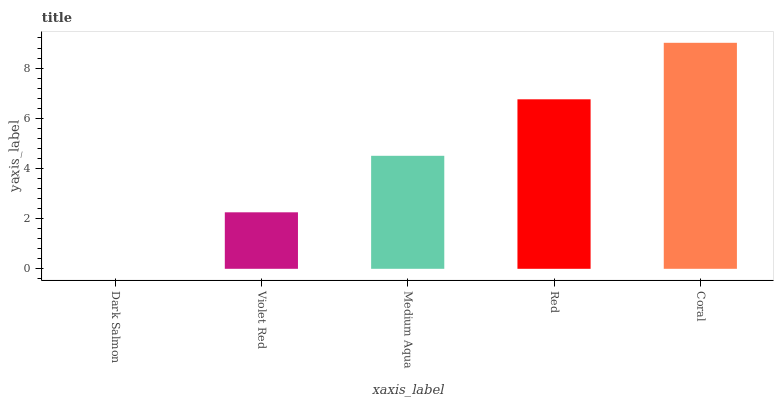Is Dark Salmon the minimum?
Answer yes or no. Yes. Is Coral the maximum?
Answer yes or no. Yes. Is Violet Red the minimum?
Answer yes or no. No. Is Violet Red the maximum?
Answer yes or no. No. Is Violet Red greater than Dark Salmon?
Answer yes or no. Yes. Is Dark Salmon less than Violet Red?
Answer yes or no. Yes. Is Dark Salmon greater than Violet Red?
Answer yes or no. No. Is Violet Red less than Dark Salmon?
Answer yes or no. No. Is Medium Aqua the high median?
Answer yes or no. Yes. Is Medium Aqua the low median?
Answer yes or no. Yes. Is Dark Salmon the high median?
Answer yes or no. No. Is Coral the low median?
Answer yes or no. No. 